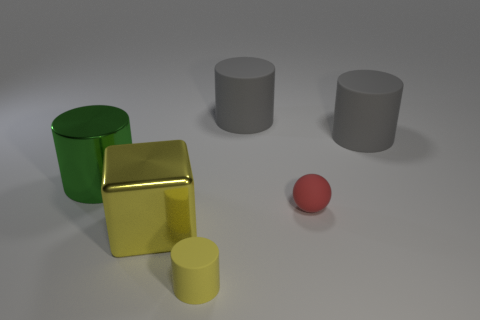What materials do the objects in the image appear to be made of? The objects in the image seem to have different material appearances. The green and yellow cylinders, as well as the grey ones, appear to have a matte finish, possibly indicative of a plastic or painted metal surface. The golden cube has a reflective surface, suggesting it could be made of a polished metal or a gold-colored reflective material. 